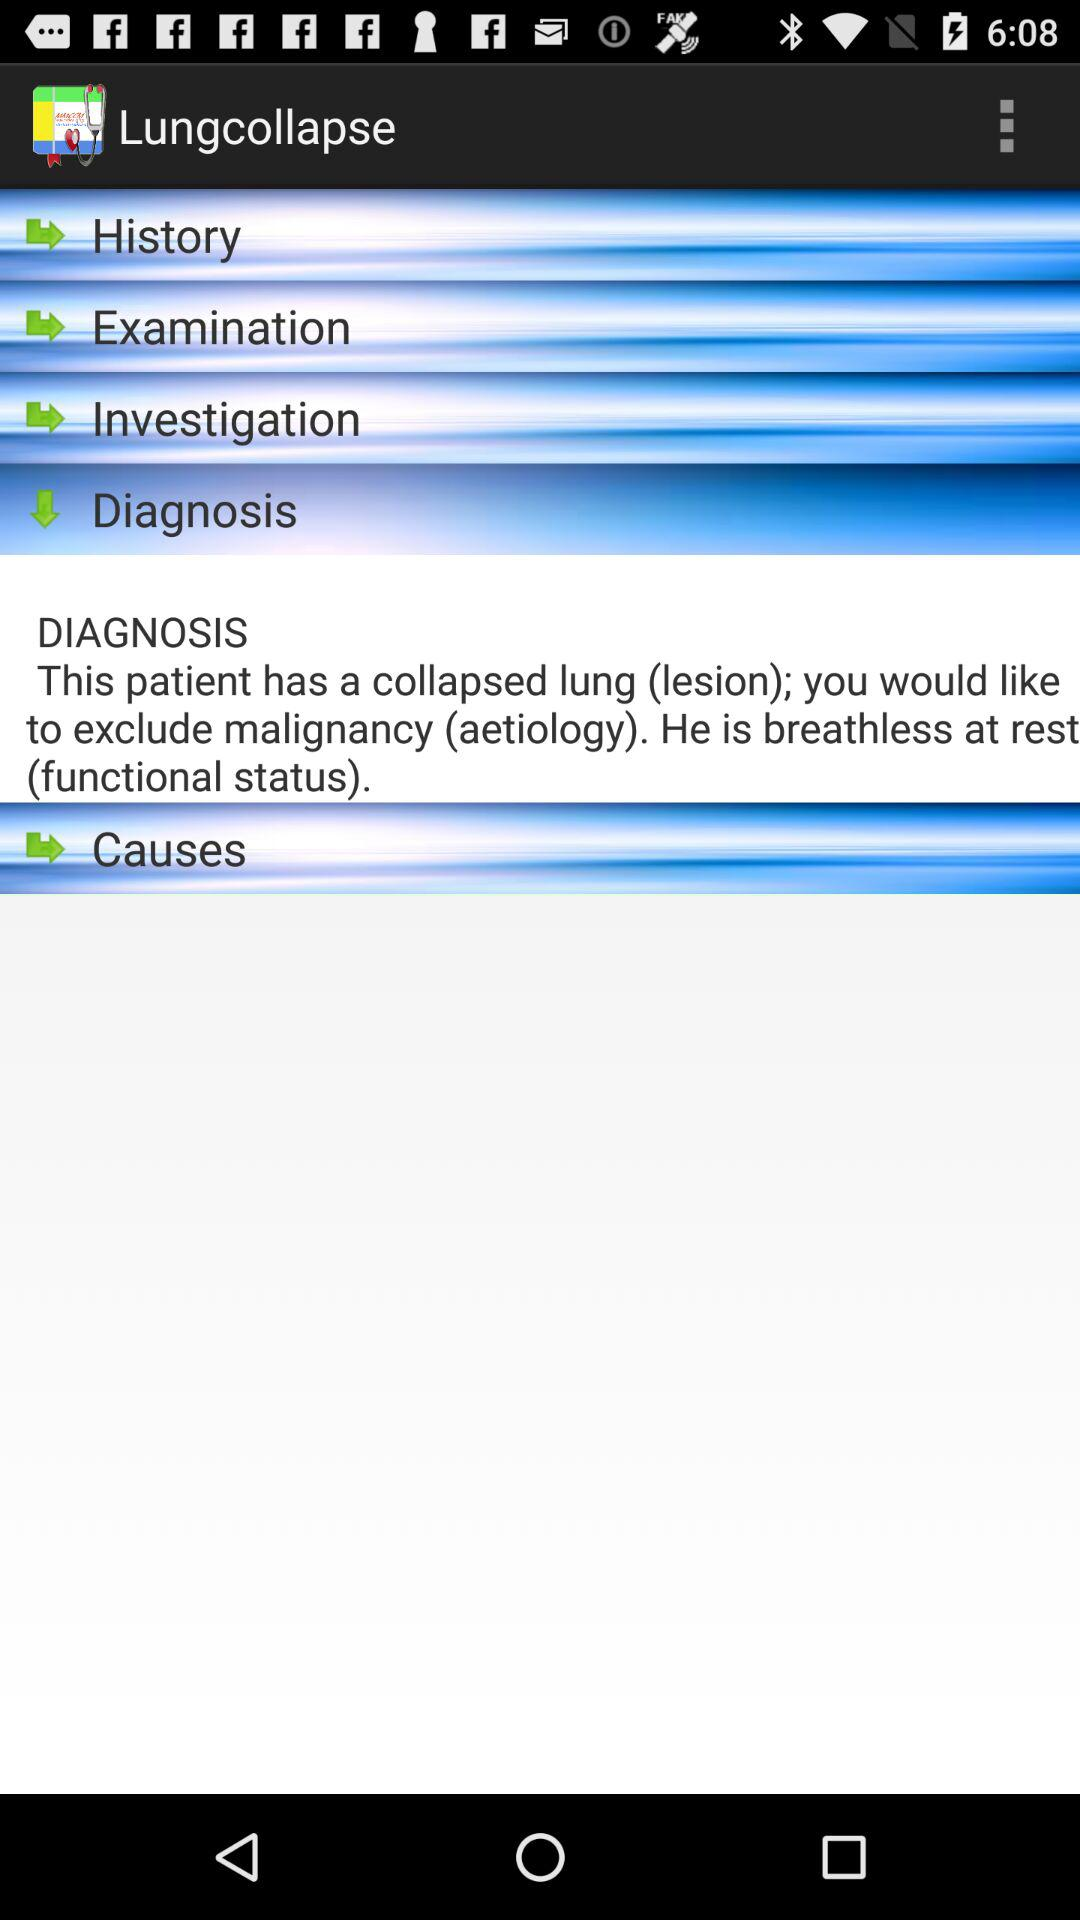What is the application name? The application name is "Lungcollapse". 